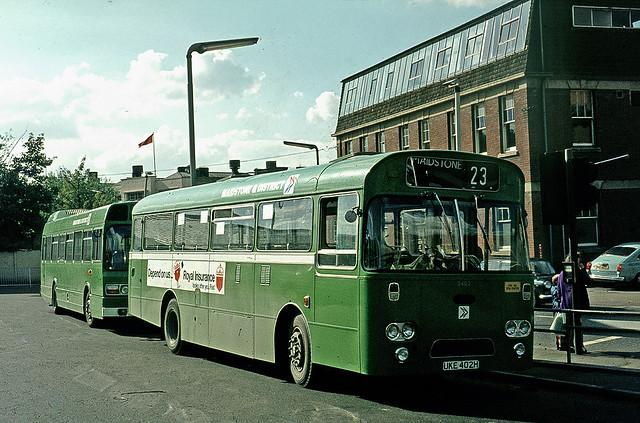What is the sum of each individual digit on the top of the bus? Please explain your reasoning. five. Two plus three equals. 